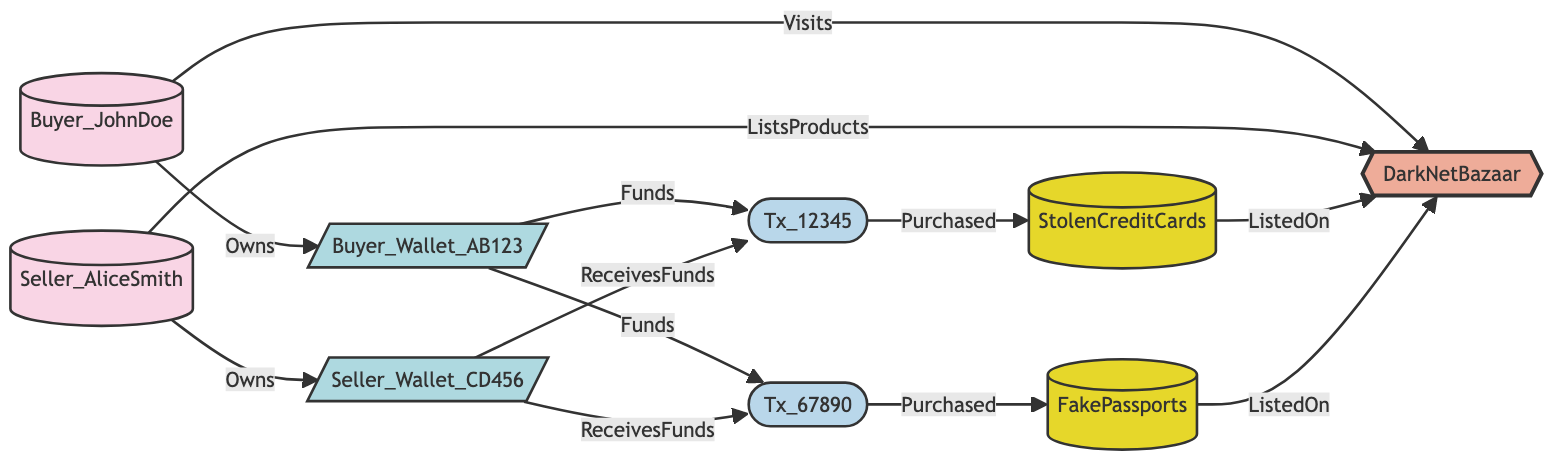What is the name of the market shown in the diagram? The node labeled "market_1" in the diagram is represented by the name "DarkNetBazaar."
Answer: DarkNetBazaar How many users are represented in the diagram? There are two user nodes, "Buyer_JohnDoe" and "Seller_AliceSmith," which can be counted directly from the nodes listed.
Answer: 2 What product did Buyer_JohnDoe purchase? The transaction node "Tx_12345" is connected to the product node "StolenCreditCards," indicating that this product was purchased by Buyer_JohnDoe.
Answer: StolenCreditCards Which crypto wallet does Seller_AliceSmith own? "Seller_Wallet_CD456" is the wallet node connected to Seller_AliceSmith, indicating that this is the wallet they own as shown in the relationships.
Answer: Seller_Wallet_CD456 How many transactions occurred in the diagram? There are two transaction nodes, "Tx_12345" and "Tx_67890," that can be seen in the transaction category of nodes.
Answer: 2 What is the relationship between Buyer_JohnDoe and DarkNetBazaar? The relationship is defined by the edge that indicates "Buyer_JohnDoe" visits "DarkNetBazaar." This specific relationship shows that they interact with the market.
Answer: Visits Which product was purchased in transaction Tx_67890? Looking at the edges, "Tx_67890" is connected to the product "FakePassports," indicating that this was purchased in that transaction.
Answer: FakePassports How does Buyer_Wallet_AB123 interact with transaction Tx_12345? The edge shows that "Buyer_Wallet_AB123" provides funds to "Tx_12345," indicating that this wallet is used to fund that particular transaction.
Answer: Funds What type of node is Seller_AliceSmith? The node "user_2" represents Seller_AliceSmith which is classified as a "User" type according to the node information described in the data.
Answer: User 